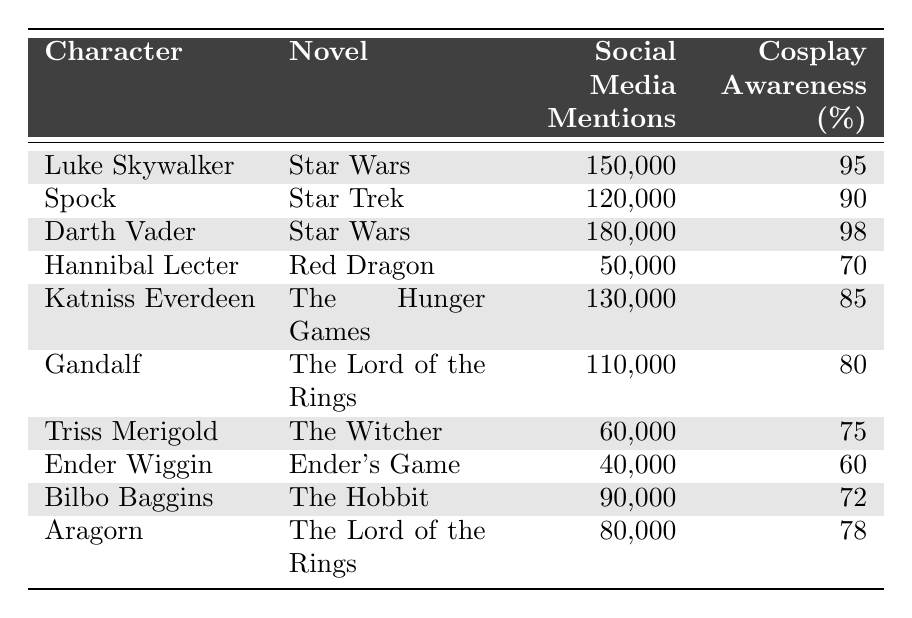What is the character with the highest number of social media mentions? By examining the table, we see that Darth Vader has the highest social media mentions at 180,000.
Answer: Darth Vader Which character has the lowest cosplay awareness percentage? The table shows that Ender Wiggin has the lowest cosplay awareness percentage at 60%.
Answer: Ender Wiggin What is the total number of social media mentions for characters from "Star Wars"? From the table, Luke Skywalker has 150,000 and Darth Vader has 180,000. Adding these gives us 150,000 + 180,000 = 330,000.
Answer: 330,000 Is the cosplay awareness for Katniss Everdeen higher than that of Gandalf? Comparing the percentages, Katniss Everdeen has 85% which is higher than Gandalf's 80%.
Answer: Yes What is the difference in social media mentions between the most and least mentioned characters? The most mentioned character is Darth Vader with 180,000 and the least is Ender Wiggin with 40,000. The difference is 180,000 - 40,000 = 140,000.
Answer: 140,000 What is the average cosplay awareness percentage for all characters from "The Lord of the Rings"? The characters are Gandalf (80%) and Aragorn (78%). The total is 80 + 78 = 158, and dividing by 2 gives an average of 158 / 2 = 79.
Answer: 79 Which character has a higher number of social media mentions, Spock or Katniss Everdeen? Spock has 120,000 mentions, while Katniss Everdeen has 130,000. Comparing both, Katniss Everdeen has more mentions.
Answer: Katniss Everdeen How many characters have a cosplay awareness of 75% or higher? The characters with 75% or higher are Luke Skywalker (95%), Darth Vader (98%), Spock (90%), Katniss Everdeen (85%), Gandalf (80%), and Aragorn (78%). That totals 6 characters.
Answer: 6 Is it true that Triss Merigold has more social media mentions than Bilbo Baggins? Checking the table, Triss Merigold has 60,000 mentions while Bilbo Baggins has 90,000. Thus, this statement is false.
Answer: No What is the combined cosplay awareness percentage of all characters from "The Hunger Games" and "The Witcher"? Katniss Everdeen (85%) and Triss Merigold (75%) are from these novels. Their combined awareness is 85 + 75 = 160, and dividing by 2 for the average gives us 160 / 2 = 80.
Answer: 80 